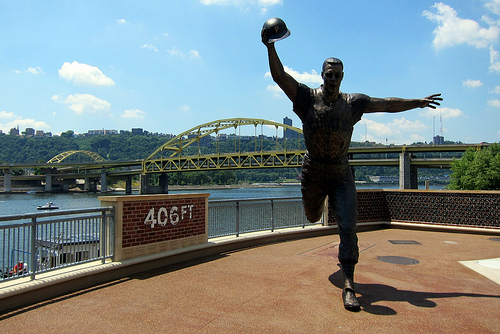<image>
Is the statue behind the bridge? No. The statue is not behind the bridge. From this viewpoint, the statue appears to be positioned elsewhere in the scene. Where is the cap in relation to the sky? Is it next to the sky? No. The cap is not positioned next to the sky. They are located in different areas of the scene. 